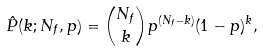<formula> <loc_0><loc_0><loc_500><loc_500>\hat { P } ( k ; N _ { f } , p ) = { N _ { f } \choose k } p ^ { ( N _ { f } - k ) } ( 1 - p ) ^ { k } ,</formula> 